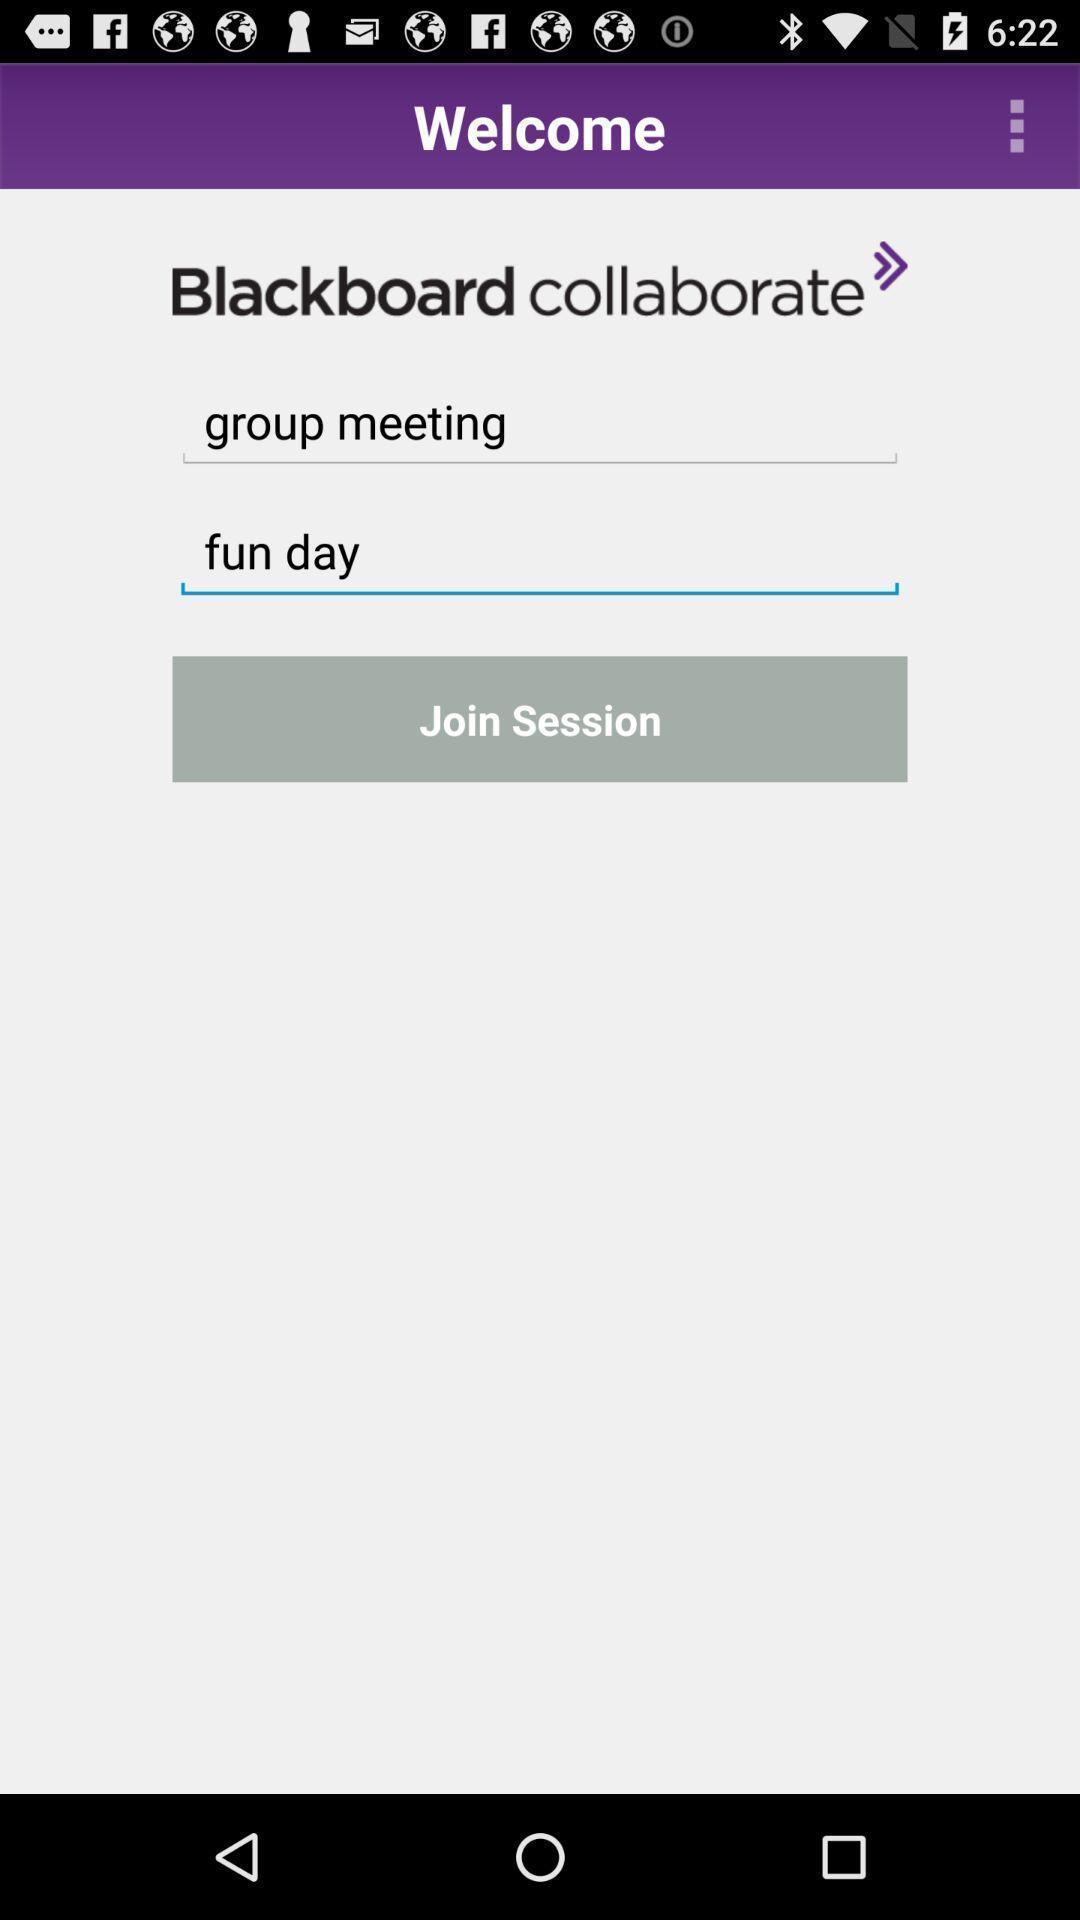Explain what's happening in this screen capture. Welcome page to join the session. 